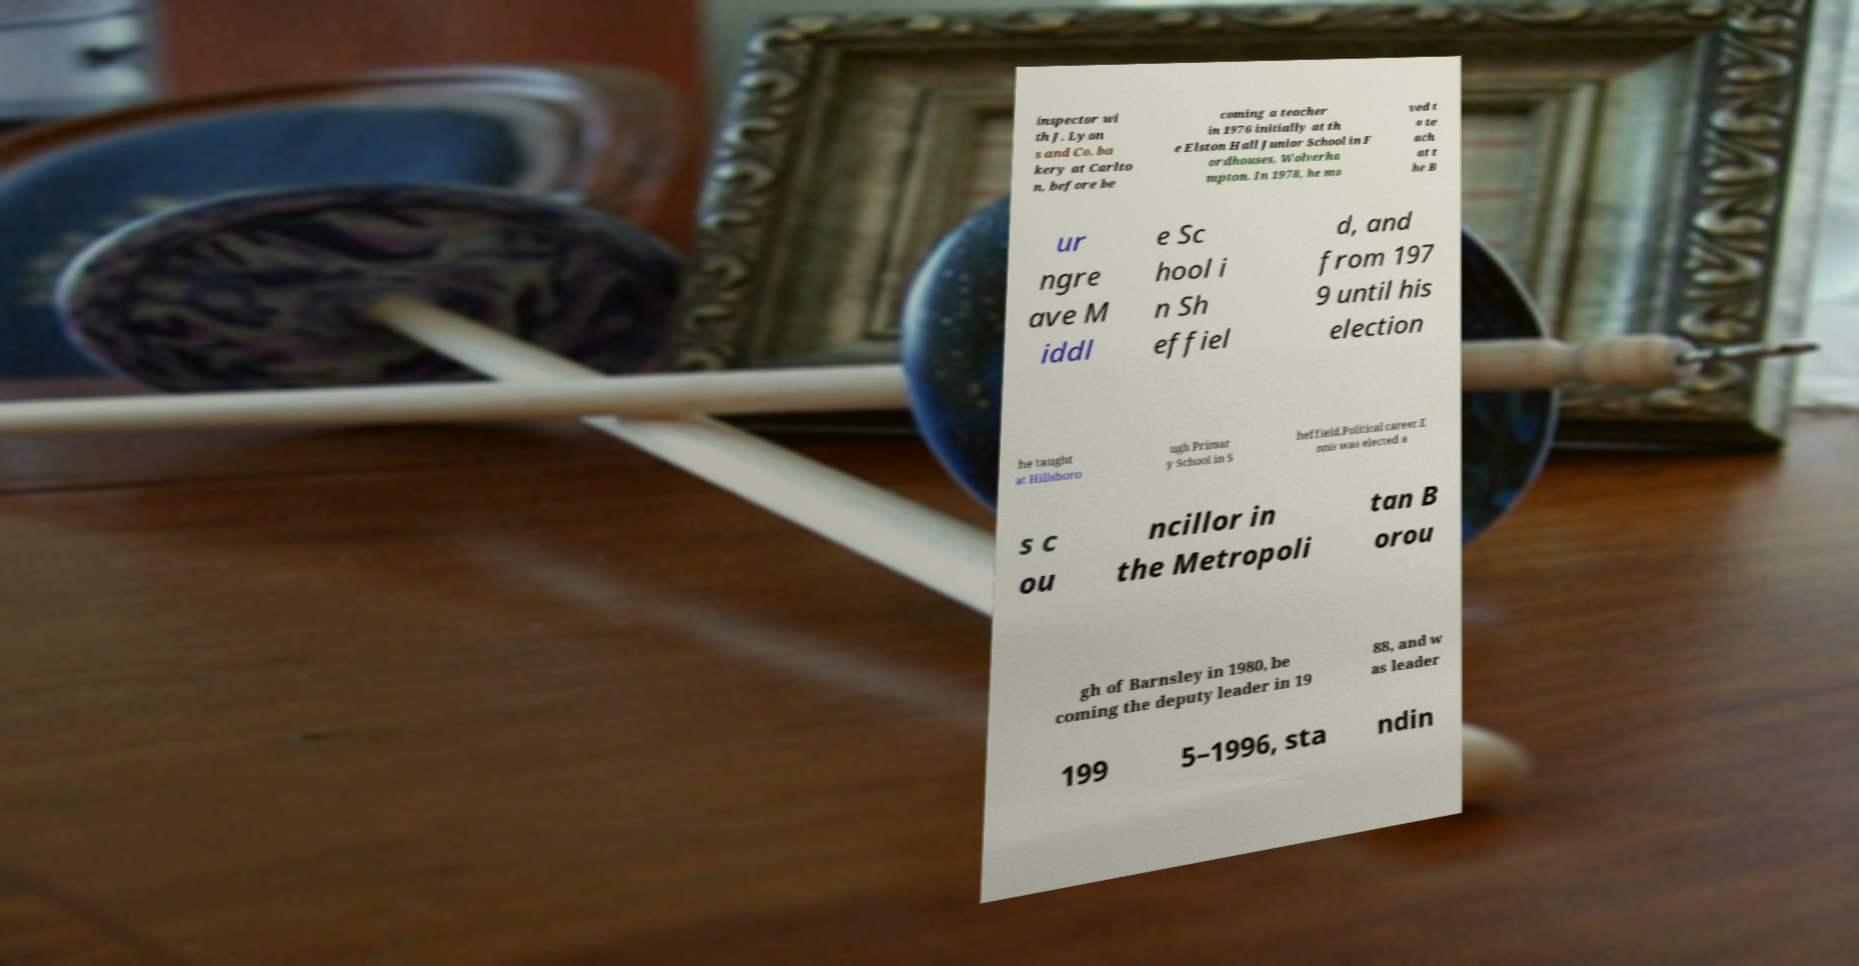What messages or text are displayed in this image? I need them in a readable, typed format. inspector wi th J. Lyon s and Co. ba kery at Carlto n, before be coming a teacher in 1976 initially at th e Elston Hall Junior School in F ordhouses, Wolverha mpton. In 1978, he mo ved t o te ach at t he B ur ngre ave M iddl e Sc hool i n Sh effiel d, and from 197 9 until his election he taught at Hillsboro ugh Primar y School in S heffield.Political career.E nnis was elected a s c ou ncillor in the Metropoli tan B orou gh of Barnsley in 1980, be coming the deputy leader in 19 88, and w as leader 199 5–1996, sta ndin 